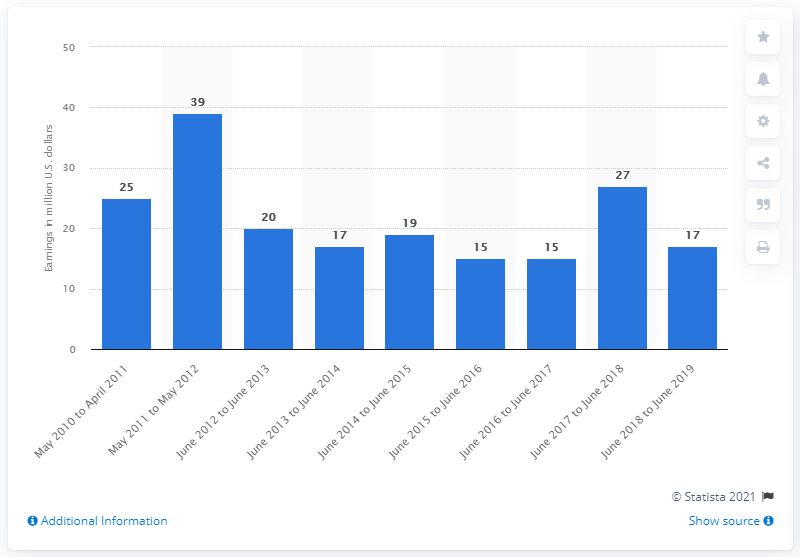Highlight a few significant elements in this photo. Stephen King earned $27,000 in the previous year. 